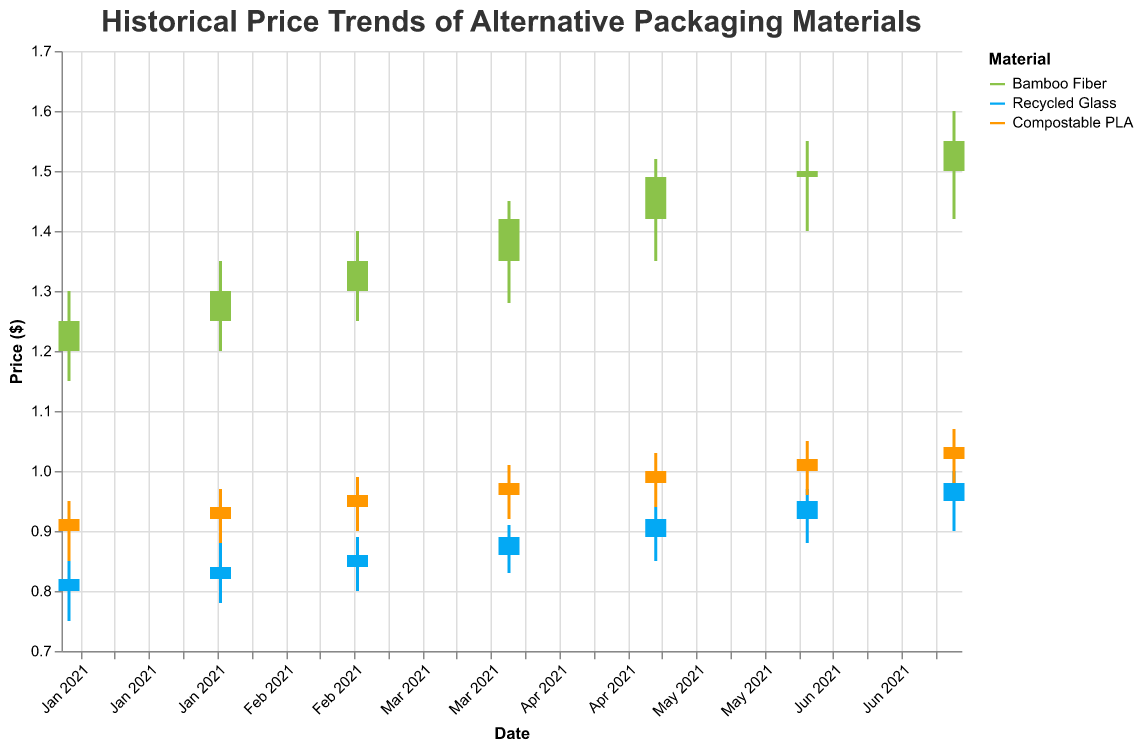Which material shows the highest price increase from January 2021 to July 2021? To determine the material with the highest price increase, compare the closing prices in January and July for each material and calculate the difference.
- Bamboo Fiber: 1.55 - 1.25 = 0.30
- Recycled Glass: 0.98 - 0.82 = 0.16
- Compostable PLA: 1.04 - 0.92 = 0.12
Bamboo Fiber has the highest price increase.
Answer: Bamboo Fiber What is the lowest price for Recycled Glass in the entire dataset? To find the lowest price for Recycled Glass, look at the 'Low' values for Recycled Glass throughout the dataset. The minimum is 0.75 on January 1, 2021.
Answer: 0.75 What is the price range of Compostable PLA in April 2021? To find the price range, subtract the 'Low' value from the 'High' value for Compostable PLA in April 2021. The values are High = 1.01 and Low = 0.92, so the range is 1.01 - 0.92 = 0.09.
Answer: 0.09 How does the price trend of Bamboo Fiber compare to Recycled Glass from March 2021 to May 2021? Examine the closing prices from March to May for both materials:
- Bamboo Fiber: March 1.35, April 1.42, May 1.49 - Shows a continuous increase.
- Recycled Glass: March 0.86, April 0.89, May 0.92 - Shows a continuous increase but at a slower rate.
Both materials show an increasing trend, but Bamboo Fiber increases more rapidly.
Answer: Bamboo Fiber increases more rapidly What is the overall trend for Compostable PLA from January 2021 to July 2021? Look at the closing prices for Compostable PLA over the months. January: 0.92, February: 0.94, March: 0.96, April: 0.98, May: 1.00, June: 1.02, July: 1.04. The prices are steadily increasing every month.
Answer: Steadily increasing During which month did Bamboo Fiber have the largest price fluctuation? To determine the largest price fluctuation, calculate the difference between the 'High' and 'Low' prices for each month for Bamboo Fiber. The largest difference occurs in July 2021 with a High of 1.60 and a Low of 1.42, giving a fluctuation of 1.60 - 1.42 = 0.18.
Answer: July 2021 What's the average closing price for Recycled Glass from January to July 2021? Add up the closing prices for Recycled Glass for each month from January to July and divide by the number of months. (0.82 + 0.84 + 0.86 + 0.89 + 0.92 + 0.95 + 0.98) / 7 = 6.26 / 7 = 0.894.
Answer: 0.894 What was the opening price of Bamboo Fiber in June 2021, and how does it compare to its closing price in the same month? The opening price of Bamboo Fiber in June 2021 was 1.49. The closing price in June 2021 was 1.50. Comparatively, the closing price is 0.01 higher than the opening price.
Answer: The closing price is 0.01 higher 